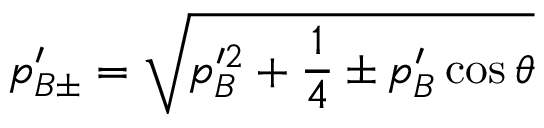Convert formula to latex. <formula><loc_0><loc_0><loc_500><loc_500>p _ { B \pm } ^ { \prime } = \sqrt { p _ { B } ^ { \prime 2 } + \frac { 1 } { 4 } \pm p _ { B } ^ { \prime } \cos \theta }</formula> 